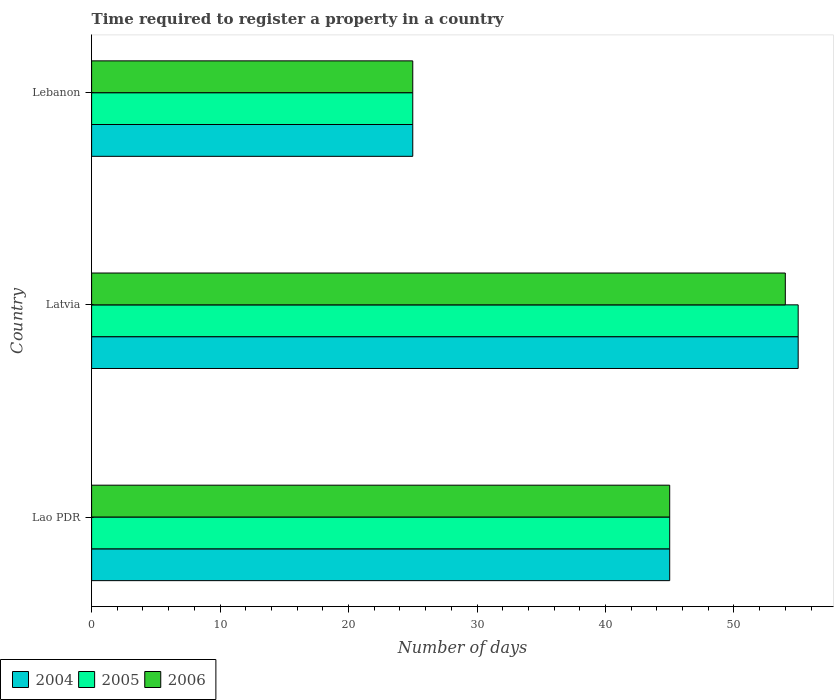How many different coloured bars are there?
Provide a short and direct response. 3. What is the label of the 3rd group of bars from the top?
Provide a short and direct response. Lao PDR. In how many cases, is the number of bars for a given country not equal to the number of legend labels?
Give a very brief answer. 0. In which country was the number of days required to register a property in 2004 maximum?
Keep it short and to the point. Latvia. In which country was the number of days required to register a property in 2006 minimum?
Provide a short and direct response. Lebanon. What is the total number of days required to register a property in 2005 in the graph?
Offer a very short reply. 125. What is the difference between the number of days required to register a property in 2004 in Lebanon and the number of days required to register a property in 2005 in Latvia?
Ensure brevity in your answer.  -30. What is the average number of days required to register a property in 2004 per country?
Ensure brevity in your answer.  41.67. What is the ratio of the number of days required to register a property in 2004 in Latvia to that in Lebanon?
Give a very brief answer. 2.2. Is the difference between the number of days required to register a property in 2004 in Latvia and Lebanon greater than the difference between the number of days required to register a property in 2006 in Latvia and Lebanon?
Your response must be concise. Yes. What is the difference between the highest and the lowest number of days required to register a property in 2004?
Your answer should be very brief. 30. Is the sum of the number of days required to register a property in 2005 in Lao PDR and Lebanon greater than the maximum number of days required to register a property in 2006 across all countries?
Keep it short and to the point. Yes. How many bars are there?
Make the answer very short. 9. Are the values on the major ticks of X-axis written in scientific E-notation?
Make the answer very short. No. Does the graph contain any zero values?
Ensure brevity in your answer.  No. Where does the legend appear in the graph?
Your answer should be very brief. Bottom left. What is the title of the graph?
Provide a succinct answer. Time required to register a property in a country. What is the label or title of the X-axis?
Make the answer very short. Number of days. What is the Number of days in 2004 in Lao PDR?
Offer a terse response. 45. What is the Number of days of 2006 in Lao PDR?
Keep it short and to the point. 45. What is the Number of days in 2004 in Latvia?
Offer a very short reply. 55. What is the Number of days in 2005 in Latvia?
Make the answer very short. 55. What is the Number of days in 2006 in Lebanon?
Your answer should be very brief. 25. Across all countries, what is the maximum Number of days of 2005?
Your answer should be compact. 55. Across all countries, what is the maximum Number of days in 2006?
Ensure brevity in your answer.  54. Across all countries, what is the minimum Number of days of 2004?
Your response must be concise. 25. Across all countries, what is the minimum Number of days in 2005?
Give a very brief answer. 25. What is the total Number of days of 2004 in the graph?
Make the answer very short. 125. What is the total Number of days of 2005 in the graph?
Your response must be concise. 125. What is the total Number of days of 2006 in the graph?
Provide a short and direct response. 124. What is the difference between the Number of days of 2006 in Lao PDR and that in Latvia?
Keep it short and to the point. -9. What is the difference between the Number of days in 2004 in Lao PDR and that in Lebanon?
Offer a very short reply. 20. What is the difference between the Number of days in 2004 in Latvia and that in Lebanon?
Offer a terse response. 30. What is the difference between the Number of days in 2005 in Latvia and that in Lebanon?
Your answer should be compact. 30. What is the difference between the Number of days of 2004 in Lao PDR and the Number of days of 2005 in Latvia?
Your answer should be very brief. -10. What is the difference between the Number of days in 2004 in Lao PDR and the Number of days in 2006 in Latvia?
Provide a short and direct response. -9. What is the difference between the Number of days of 2005 in Lao PDR and the Number of days of 2006 in Lebanon?
Make the answer very short. 20. What is the difference between the Number of days of 2004 in Latvia and the Number of days of 2006 in Lebanon?
Your response must be concise. 30. What is the difference between the Number of days in 2005 in Latvia and the Number of days in 2006 in Lebanon?
Provide a succinct answer. 30. What is the average Number of days in 2004 per country?
Your response must be concise. 41.67. What is the average Number of days in 2005 per country?
Your answer should be very brief. 41.67. What is the average Number of days of 2006 per country?
Provide a short and direct response. 41.33. What is the difference between the Number of days in 2004 and Number of days in 2005 in Lao PDR?
Keep it short and to the point. 0. What is the difference between the Number of days of 2004 and Number of days of 2006 in Lao PDR?
Ensure brevity in your answer.  0. What is the difference between the Number of days of 2005 and Number of days of 2006 in Lao PDR?
Your response must be concise. 0. What is the difference between the Number of days in 2004 and Number of days in 2005 in Latvia?
Provide a short and direct response. 0. What is the difference between the Number of days in 2004 and Number of days in 2006 in Latvia?
Offer a very short reply. 1. What is the difference between the Number of days in 2005 and Number of days in 2006 in Lebanon?
Your response must be concise. 0. What is the ratio of the Number of days in 2004 in Lao PDR to that in Latvia?
Make the answer very short. 0.82. What is the ratio of the Number of days of 2005 in Lao PDR to that in Latvia?
Provide a short and direct response. 0.82. What is the ratio of the Number of days in 2006 in Lao PDR to that in Latvia?
Your answer should be very brief. 0.83. What is the ratio of the Number of days in 2005 in Lao PDR to that in Lebanon?
Provide a short and direct response. 1.8. What is the ratio of the Number of days in 2004 in Latvia to that in Lebanon?
Your answer should be compact. 2.2. What is the ratio of the Number of days of 2005 in Latvia to that in Lebanon?
Offer a terse response. 2.2. What is the ratio of the Number of days in 2006 in Latvia to that in Lebanon?
Provide a short and direct response. 2.16. What is the difference between the highest and the second highest Number of days of 2006?
Ensure brevity in your answer.  9. What is the difference between the highest and the lowest Number of days in 2004?
Your answer should be very brief. 30. What is the difference between the highest and the lowest Number of days in 2006?
Provide a short and direct response. 29. 